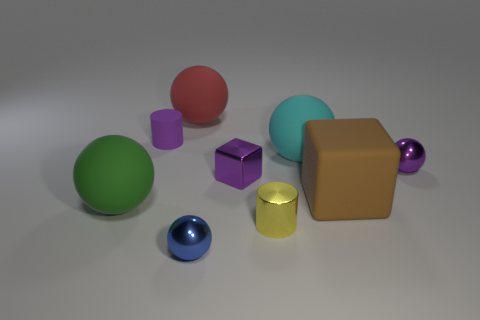Is the number of tiny matte cylinders that are on the right side of the tiny purple matte object less than the number of large purple rubber cubes?
Your response must be concise. No. What is the color of the metallic ball on the right side of the small metal sphere that is in front of the green rubber object?
Make the answer very short. Purple. What is the size of the rubber sphere that is behind the small cylinder that is behind the large matte ball that is on the left side of the red rubber thing?
Your response must be concise. Large. Are there fewer green spheres to the left of the tiny blue shiny sphere than big spheres that are in front of the small rubber thing?
Ensure brevity in your answer.  Yes. What number of other cylinders have the same material as the tiny yellow cylinder?
Provide a succinct answer. 0. There is a rubber ball that is in front of the tiny sphere behind the tiny blue sphere; is there a small purple cube that is to the left of it?
Offer a terse response. No. The yellow thing that is made of the same material as the small purple cube is what shape?
Your answer should be very brief. Cylinder. Are there more big cyan matte things than small green metallic cylinders?
Give a very brief answer. Yes. There is a red object; is its shape the same as the cyan object to the left of the small purple sphere?
Provide a succinct answer. Yes. What is the large block made of?
Keep it short and to the point. Rubber. 